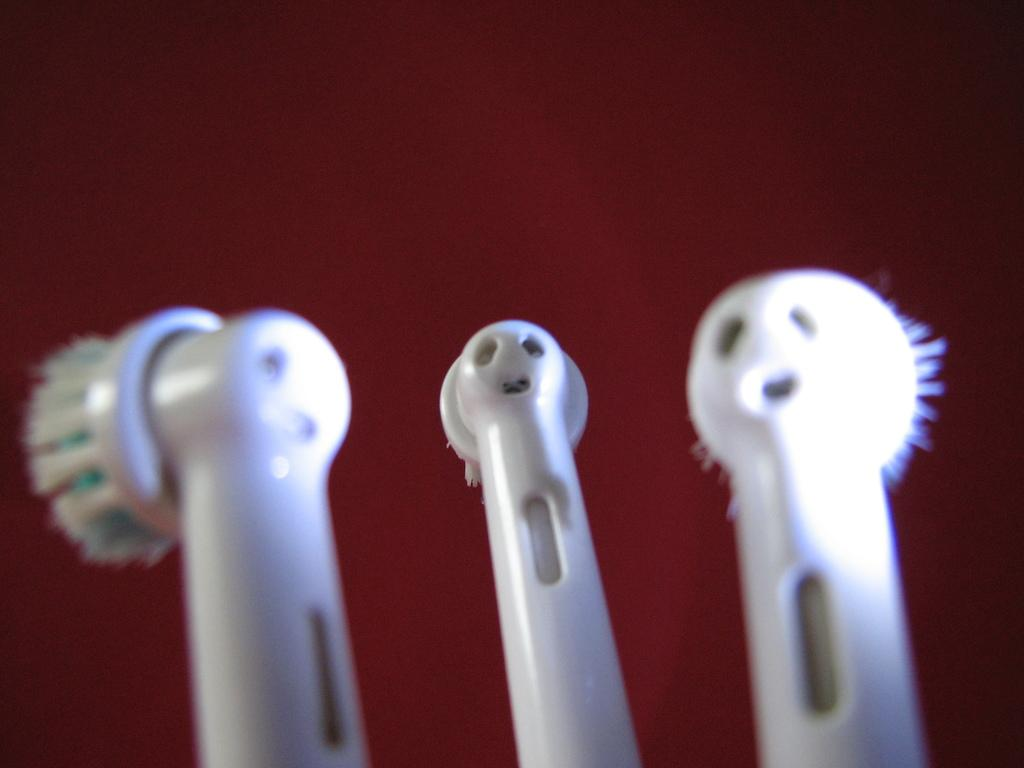How many electric toothbrushes are in the image? There are three electric toothbrushes in the image. What color are the toothbrushes? The toothbrushes are white in color. What color is the background of the image? The background of the image is maroon in color. What type of honey is being used by the zebra in the image? There is no zebra or honey present in the image; it only features three white electric toothbrushes against a maroon background. 